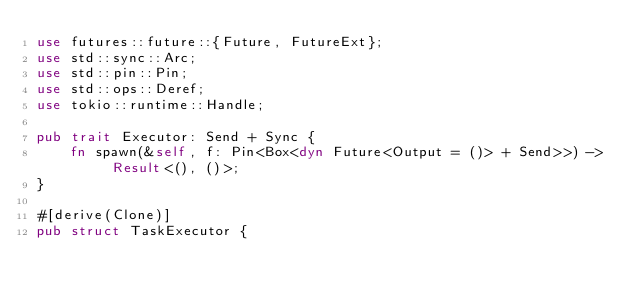Convert code to text. <code><loc_0><loc_0><loc_500><loc_500><_Rust_>use futures::future::{Future, FutureExt};
use std::sync::Arc;
use std::pin::Pin;
use std::ops::Deref;
use tokio::runtime::Handle;

pub trait Executor: Send + Sync {
    fn spawn(&self, f: Pin<Box<dyn Future<Output = ()> + Send>>) -> Result<(), ()>;
}

#[derive(Clone)]
pub struct TaskExecutor {</code> 